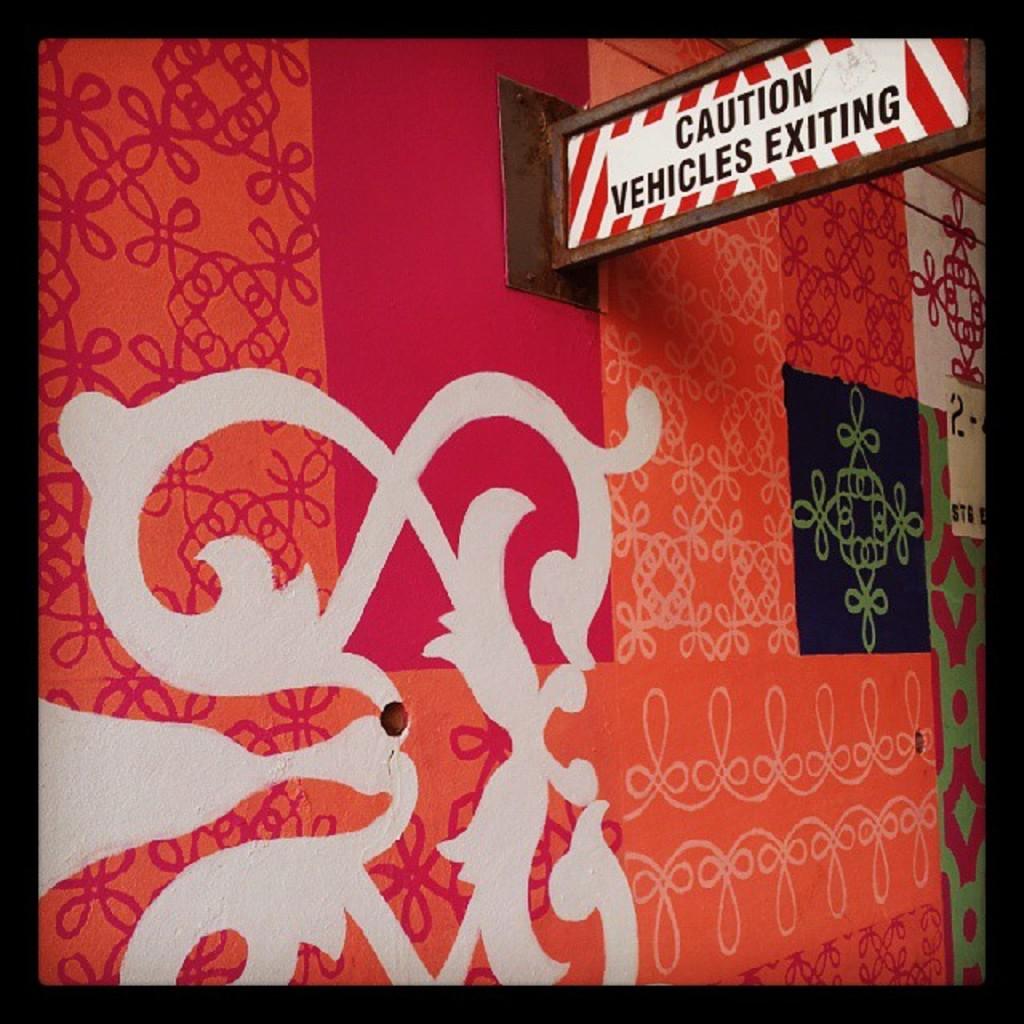What should you be cautioned about?
Your answer should be compact. Vehicles exiting. What is exiting?
Provide a short and direct response. Vehicles. 